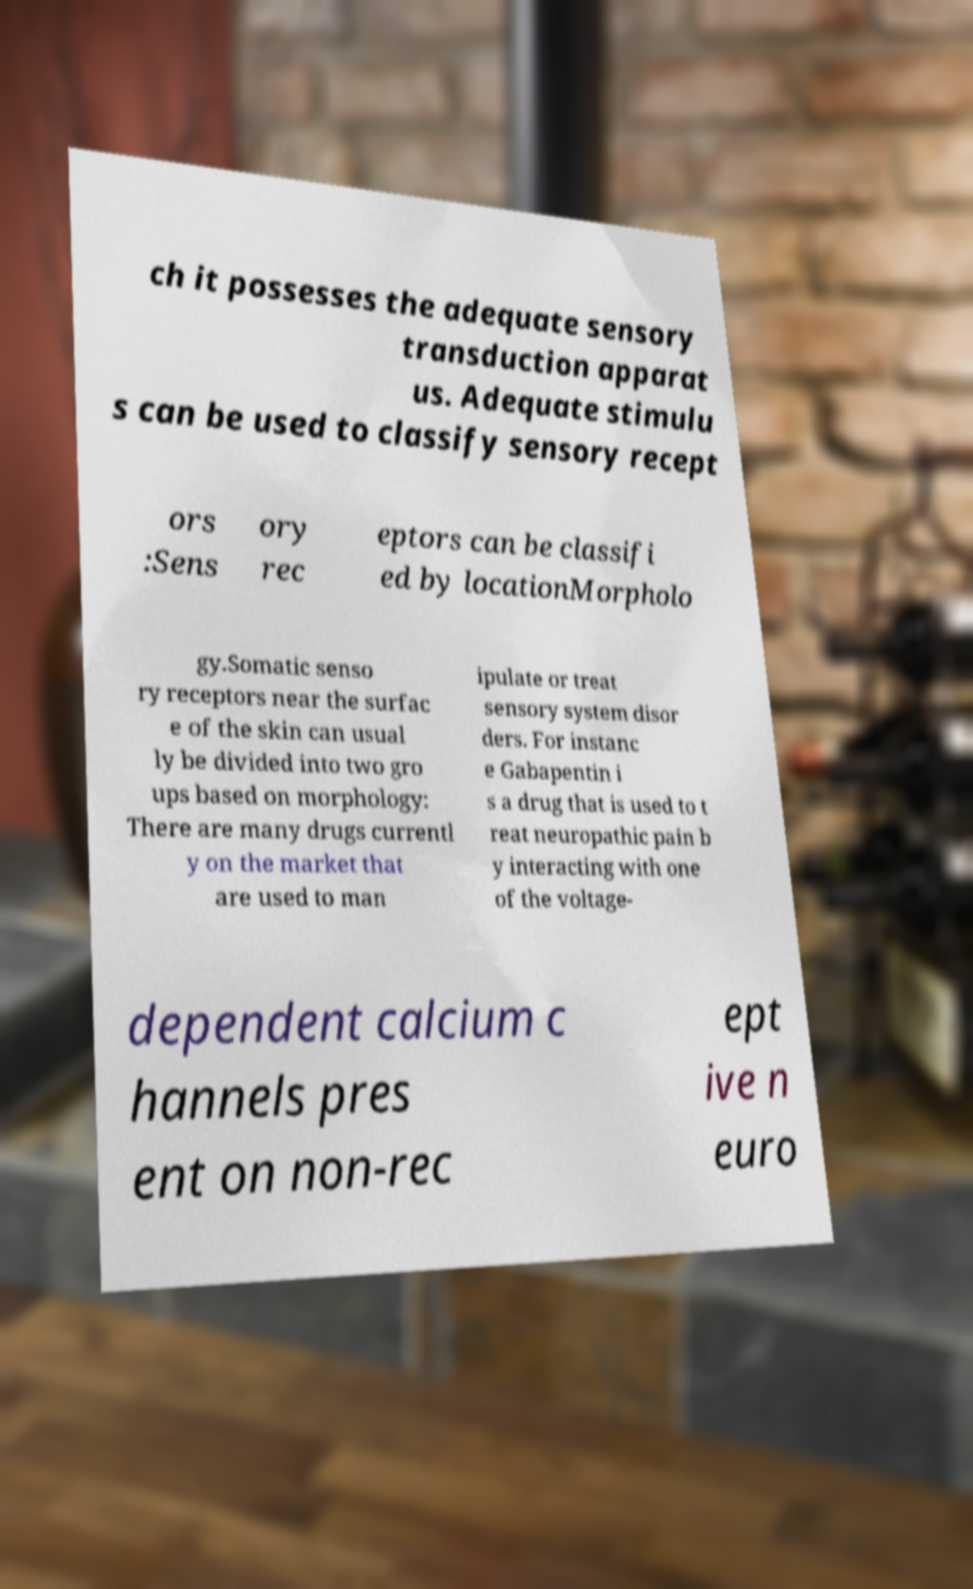Could you assist in decoding the text presented in this image and type it out clearly? ch it possesses the adequate sensory transduction apparat us. Adequate stimulu s can be used to classify sensory recept ors :Sens ory rec eptors can be classifi ed by locationMorpholo gy.Somatic senso ry receptors near the surfac e of the skin can usual ly be divided into two gro ups based on morphology: There are many drugs currentl y on the market that are used to man ipulate or treat sensory system disor ders. For instanc e Gabapentin i s a drug that is used to t reat neuropathic pain b y interacting with one of the voltage- dependent calcium c hannels pres ent on non-rec ept ive n euro 